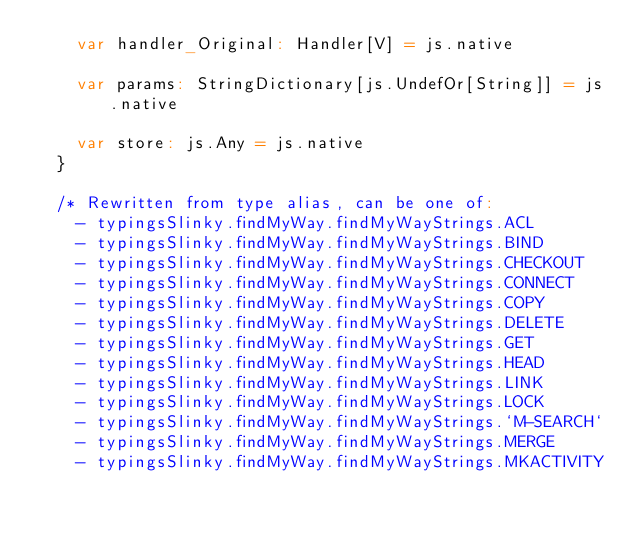<code> <loc_0><loc_0><loc_500><loc_500><_Scala_>    var handler_Original: Handler[V] = js.native
    
    var params: StringDictionary[js.UndefOr[String]] = js.native
    
    var store: js.Any = js.native
  }
  
  /* Rewritten from type alias, can be one of: 
    - typingsSlinky.findMyWay.findMyWayStrings.ACL
    - typingsSlinky.findMyWay.findMyWayStrings.BIND
    - typingsSlinky.findMyWay.findMyWayStrings.CHECKOUT
    - typingsSlinky.findMyWay.findMyWayStrings.CONNECT
    - typingsSlinky.findMyWay.findMyWayStrings.COPY
    - typingsSlinky.findMyWay.findMyWayStrings.DELETE
    - typingsSlinky.findMyWay.findMyWayStrings.GET
    - typingsSlinky.findMyWay.findMyWayStrings.HEAD
    - typingsSlinky.findMyWay.findMyWayStrings.LINK
    - typingsSlinky.findMyWay.findMyWayStrings.LOCK
    - typingsSlinky.findMyWay.findMyWayStrings.`M-SEARCH`
    - typingsSlinky.findMyWay.findMyWayStrings.MERGE
    - typingsSlinky.findMyWay.findMyWayStrings.MKACTIVITY</code> 